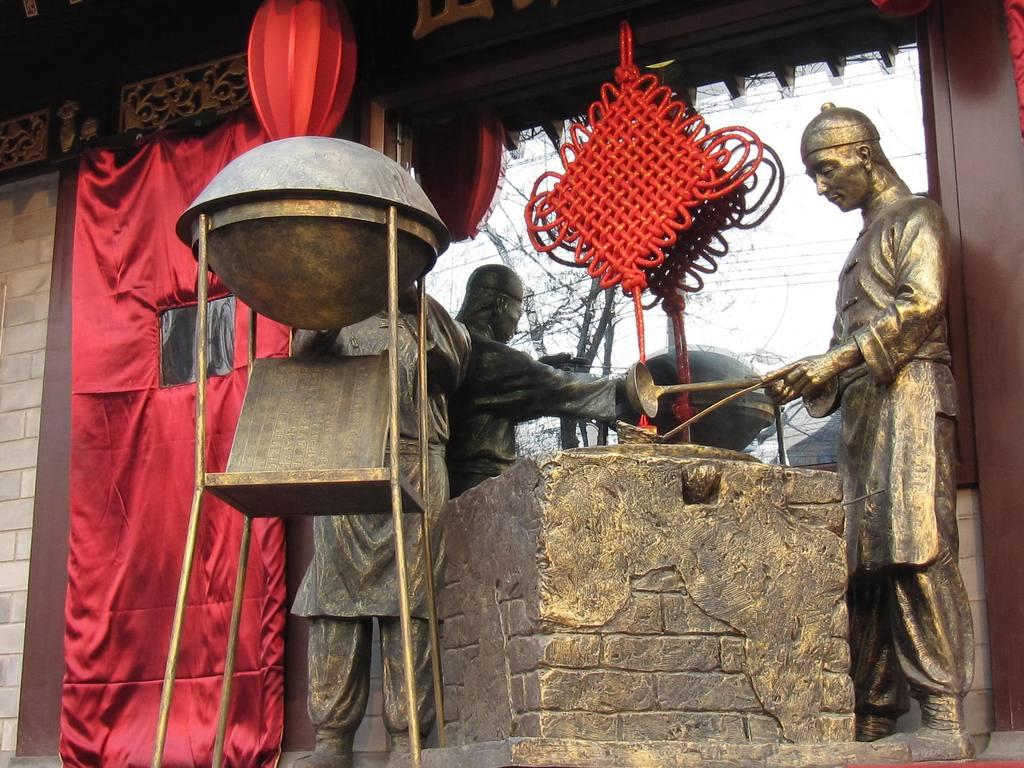What is the main subject in the image? There is a statue in the image. What is the statue holding in its hands? The statue is holding a spoon in its hands. What can be seen in the background of the image? There is a wall in the image. What type of door is present in the image? There is a glass door in the image. What color is the curtain in the image? There is a red color curtain in the image. What type of suit is the statue wearing in the image? The statue is not wearing a suit in the image; it is a statue made of a material that does not require clothing. 